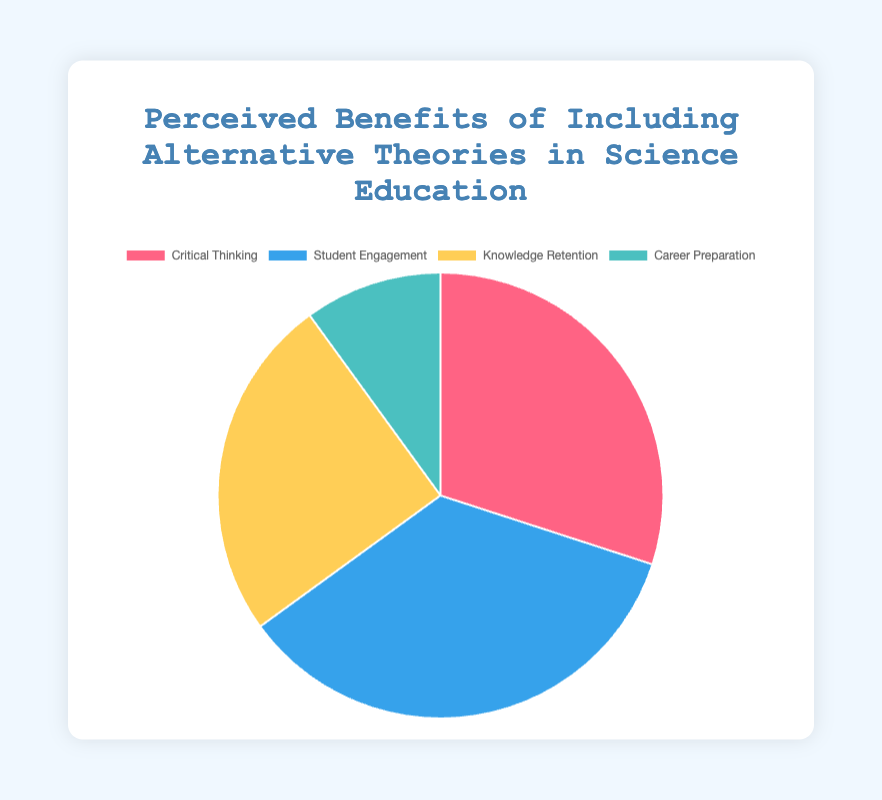What is the most highly perceived benefit of including alternative theories in science education? The pie chart shows different perceived benefits with their respective percentages. By looking at the slice with the largest area, we can see that Student Engagement has the highest value at 35%.
Answer: Student Engagement Which visual segment has the smallest representation and what benefit does it correspond to? By examining the pie chart, the smallest slice corresponds to the benefit with the least percentage. In this case, it's Career Preparation with 10%.
Answer: Career Preparation If we sum up the perceived benefits of Knowledge Retention and Career Preparation from the inclusion of alternative theories, what is the total percentage? Adding the values of Knowledge Retention (25%) and Career Preparation (10%), the total is 25 + 10 = 35%.
Answer: 35% How does the perceived benefit of Critical Thinking in the inclusion of alternative theories compare to that in the standard curriculum? Critical Thinking for inclusion of alternative theories is 30%, while for the standard curriculum, it is 20%. 30% is greater than 20%.
Answer: Higher Which two categories have equal percentages for the inclusion of alternative theories approach? Looking at the pie chart, Knowledge Retention and Career Preparation categories are distinct but Knowledge Retention (25%) and Career Preparation (10%) reveal that there is not an equal percentage between any two categories.
Answer: None What is the combined percentage of Student Engagement and Critical Thinking in the inclusion of alternative theories? Adding the values of Student Engagement (35%) and Critical Thinking (30%), the total is 35 + 30 = 65%.
Answer: 65% Which colored segment represents Knowledge Retention and what is its percentage? The segment representing Knowledge Retention is in yellow color and its percentage is 25%.
Answer: Yellow, 25% Is the percentage of Career Preparation higher or lower than that of Critical Thinking for the inclusion of alternative theories? Comparing the percentages, Career Preparation is 10% and Critical Thinking is 30%, showing Career Preparation is lower.
Answer: Lower How much more percentage does Student Engagement have compared to Career Preparation in the inclusion of alternative theories? Subtracting the percentage of Career Preparation (10%) from Student Engagement (35%), we get 35 - 10 = 25%.
Answer: 25% If we average the perceived benefits of Critical Thinking, Knowledge Retention, and Career Preparation for the inclusion of alternative theories, what is the average percentage? Adding Critical Thinking (30%), Knowledge Retention (25%), and Career Preparation (10%) gives a total of 30 + 25 + 10 = 65%. Dividing this by 3, the average is 65 / 3 = 21.67%.
Answer: 21.67% 